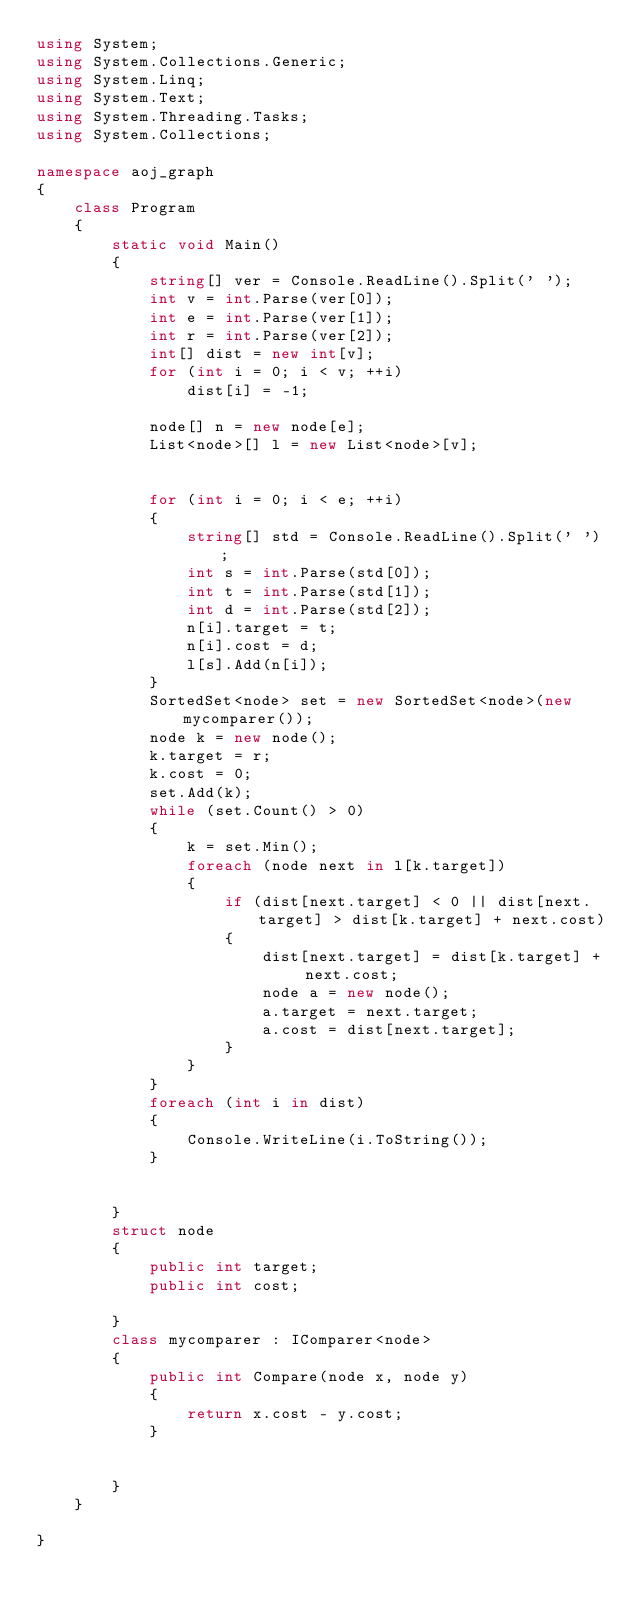<code> <loc_0><loc_0><loc_500><loc_500><_C#_>using System;
using System.Collections.Generic;
using System.Linq;
using System.Text;
using System.Threading.Tasks;
using System.Collections;

namespace aoj_graph
{
    class Program
    {
        static void Main()
        {
            string[] ver = Console.ReadLine().Split(' ');
            int v = int.Parse(ver[0]);
            int e = int.Parse(ver[1]);
            int r = int.Parse(ver[2]);
            int[] dist = new int[v];
            for (int i = 0; i < v; ++i)
                dist[i] = -1;

            node[] n = new node[e];
            List<node>[] l = new List<node>[v];

            
            for (int i = 0; i < e; ++i) 
            {
                string[] std = Console.ReadLine().Split(' ');
                int s = int.Parse(std[0]);
                int t = int.Parse(std[1]);
                int d = int.Parse(std[2]);
                n[i].target = t;
                n[i].cost = d;
                l[s].Add(n[i]);
            }
            SortedSet<node> set = new SortedSet<node>(new mycomparer());
            node k = new node();
            k.target = r;
            k.cost = 0;
            set.Add(k);
            while (set.Count() > 0) 
            {
                k = set.Min();
                foreach (node next in l[k.target]) 
                {
                    if (dist[next.target] < 0 || dist[next.target] > dist[k.target] + next.cost) 
                    {
                        dist[next.target] = dist[k.target] + next.cost;
                        node a = new node();
                        a.target = next.target;
                        a.cost = dist[next.target];
                    }
                }
            }
            foreach (int i in dist) 
            {
                Console.WriteLine(i.ToString());
            }


        }
        struct node 
        {
            public int target;
            public int cost;

        }
        class mycomparer : IComparer<node> 
        {
            public int Compare(node x, node y) 
            {
                return x.cost - y.cost;
            }


        }
    }

}</code> 